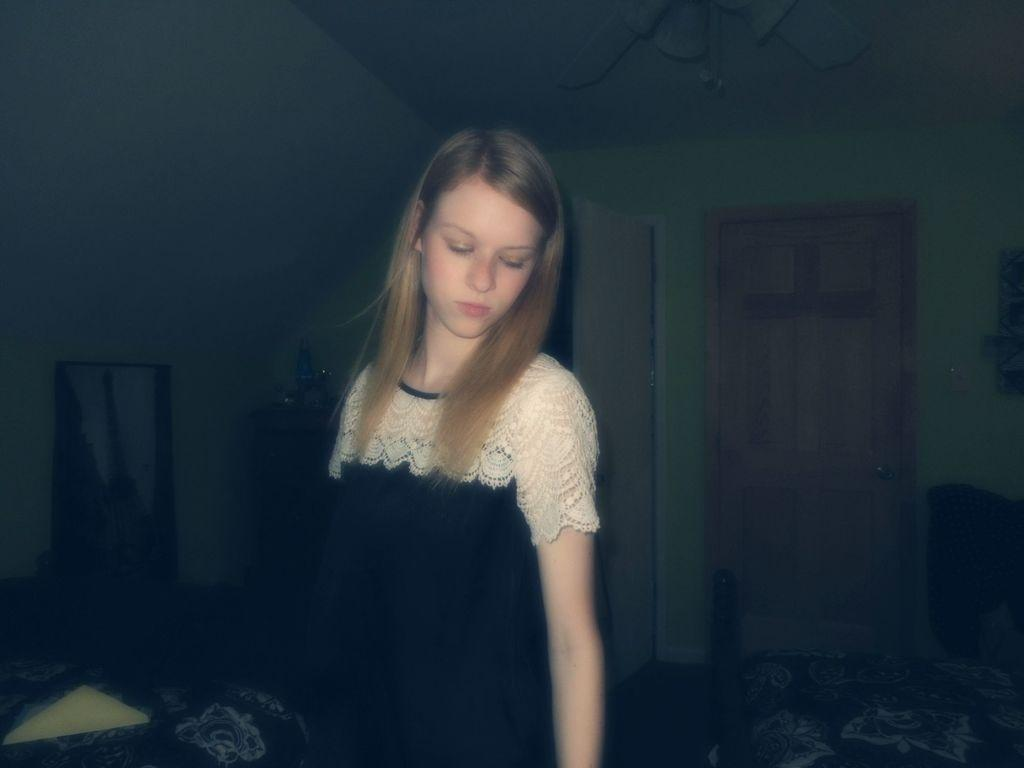Who is present in the image? There is a girl in the image. What is the girl wearing? The girl is wearing clothes. What architectural features can be seen in the image? There is a door and a wall in the image. What surface is the girl standing on? There is a floor in the image. How would you describe the overall color scheme of the image? The background of the image is pale dark. What type of apparel is the girl wearing to enhance her pleasure in the image? There is no indication in the image that the girl is wearing any specific apparel for pleasure. 